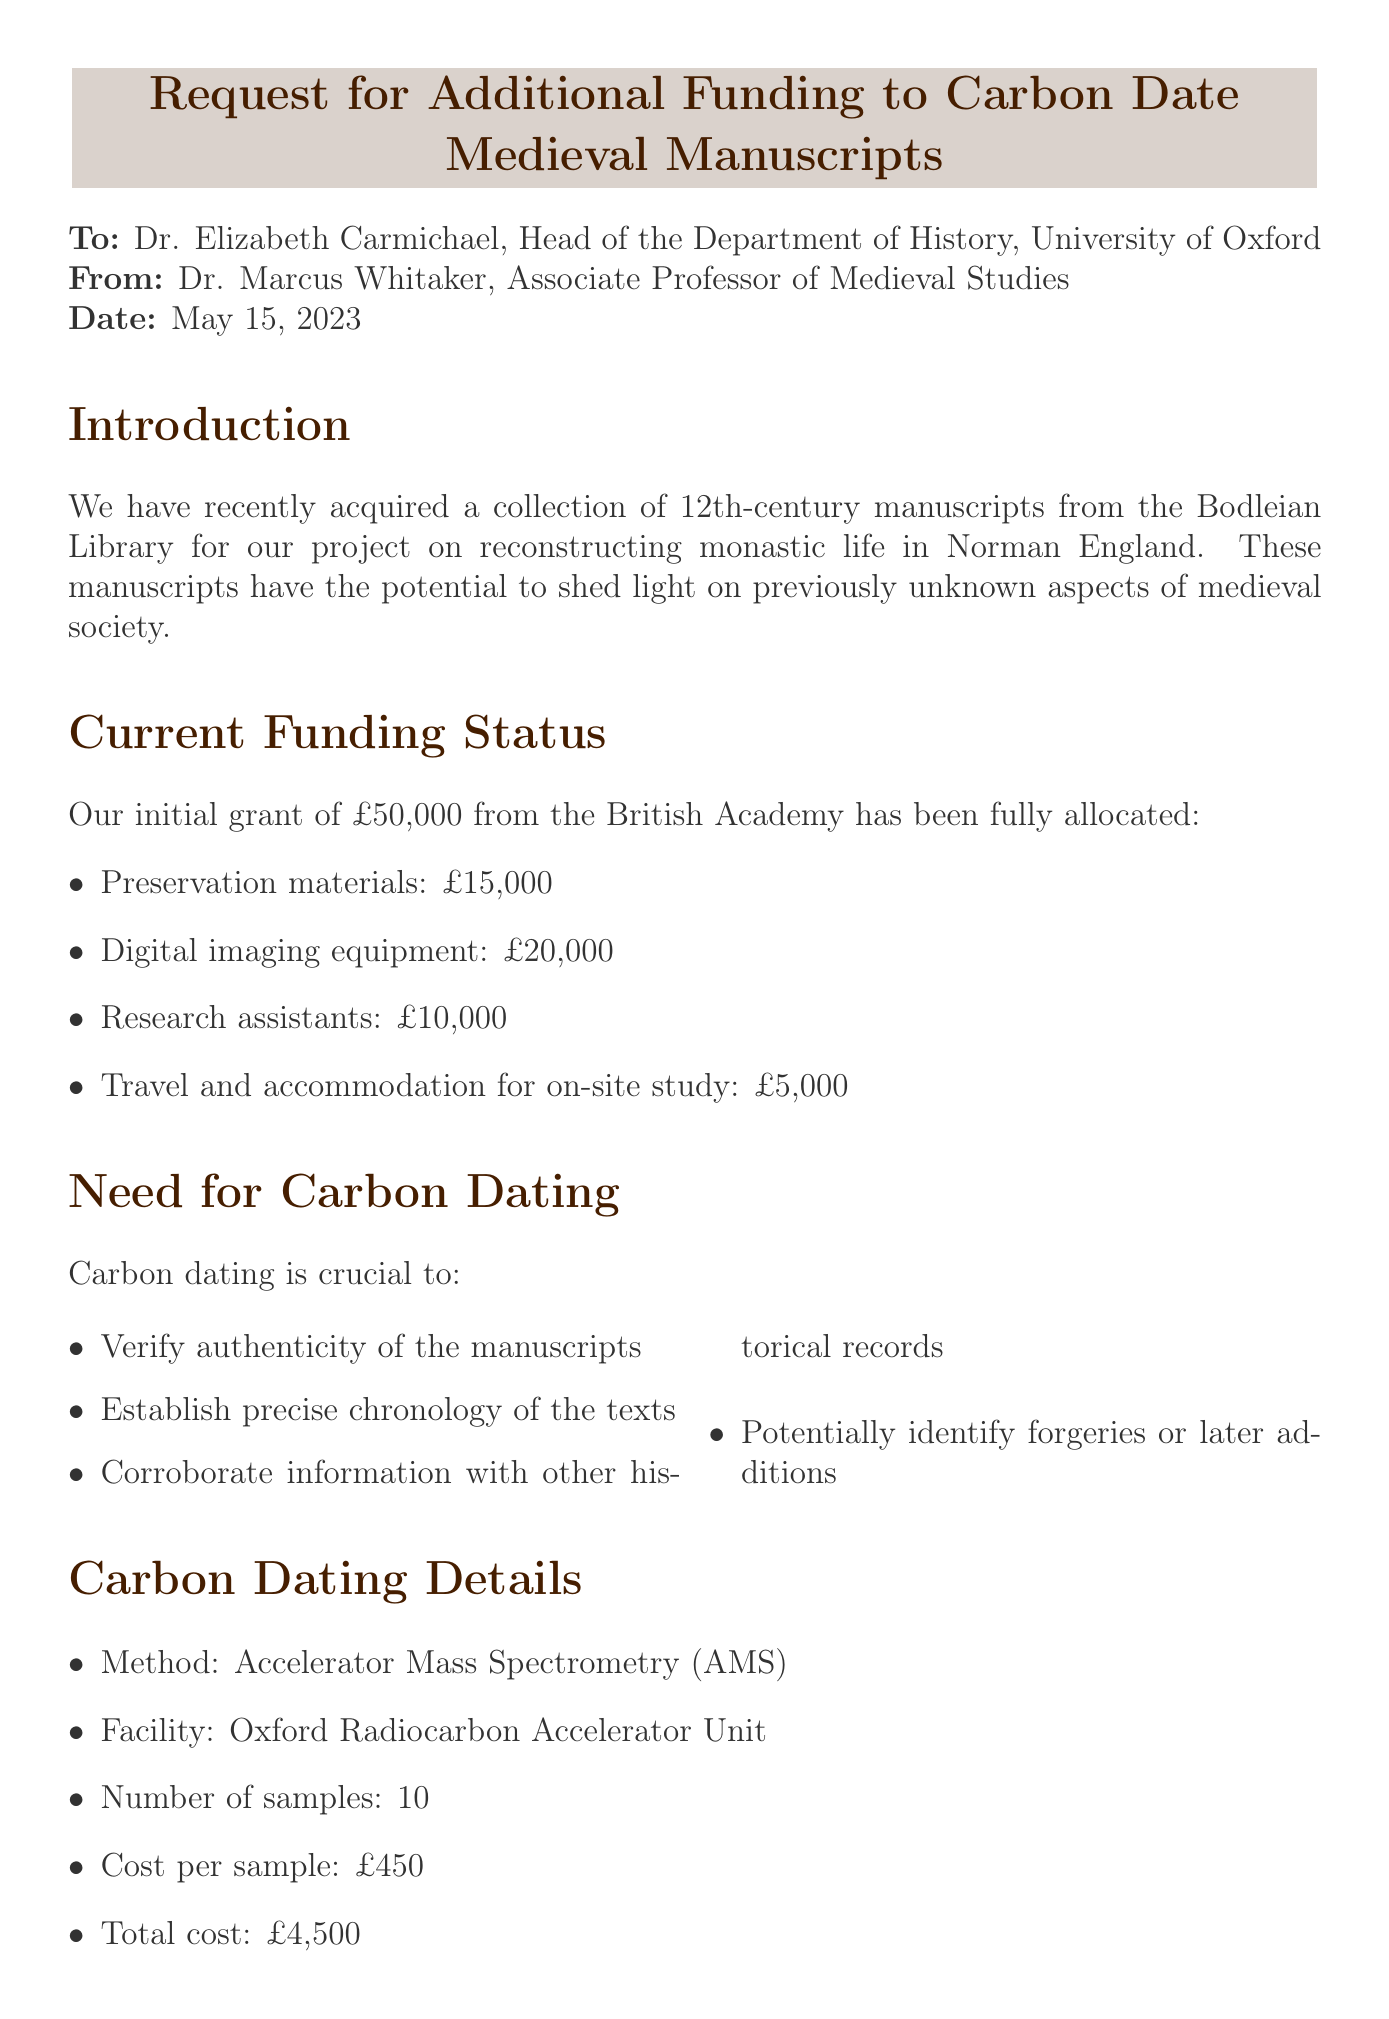what is the memo title? The memo title is provided at the beginning of the document.
Answer: Request for Additional Funding to Carbon Date Medieval Manuscripts who is the recipient of the memo? The recipient's name and position are mentioned in the memo.
Answer: Dr. Elizabeth Carmichael what is the total cost for carbon dating? The total cost for carbon dating is calculated from the number of samples and cost per sample in the document.
Answer: £4,500 what is the total funding requested? The total funding requested is explicitly stated toward the end of the document.
Answer: £7,000 what method will be used for carbon dating? The method for carbon dating is specified in the section detailing carbon dating.
Answer: Accelerator Mass Spectrometry (AMS) why is carbon dating needed? The reasons for carbon dating are listed in the need for carbon dating section.
Answer: Verify authenticity of the manuscripts how many samples will be tested for carbon dating? The document specifies the number of samples to be tested in the carbon dating details.
Answer: 10 what is the timeline for sample preparation? The timeline is provided for various phases, including sample preparation.
Answer: 2 weeks who is the sender of the memo? The sender's name and position are mentioned at the beginning of the memo.
Answer: Dr. Marcus Whitaker 